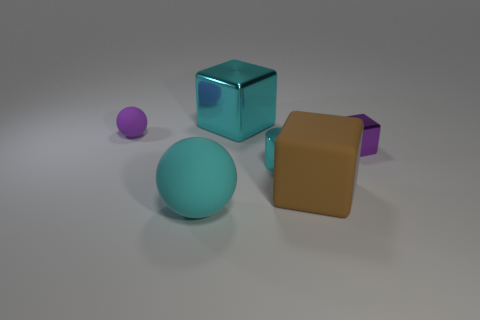There is a big cube that is behind the purple thing that is to the right of the tiny matte ball; what number of big brown matte things are right of it?
Give a very brief answer. 1. There is a tiny thing that is both behind the cyan metallic cylinder and on the left side of the brown rubber thing; what is its color?
Give a very brief answer. Purple. How many tiny matte spheres have the same color as the small shiny cylinder?
Provide a short and direct response. 0. How many balls are tiny purple matte things or purple metallic things?
Keep it short and to the point. 1. What color is the rubber thing that is the same size as the shiny cylinder?
Offer a very short reply. Purple. There is a big thing behind the tiny object that is left of the large cyan metal block; are there any big brown objects left of it?
Your response must be concise. No. The purple block has what size?
Ensure brevity in your answer.  Small. How many things are big cyan cubes or large objects?
Ensure brevity in your answer.  3. There is another large ball that is made of the same material as the purple ball; what color is it?
Your answer should be compact. Cyan. There is a rubber thing behind the large brown rubber thing; does it have the same shape as the cyan matte object?
Offer a terse response. Yes. 